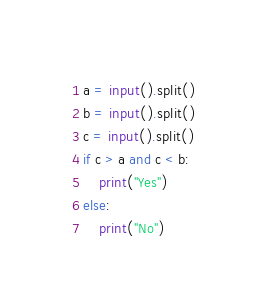Convert code to text. <code><loc_0><loc_0><loc_500><loc_500><_Python_>a = input().split()
b = input().split()
c = input().split()
if c > a and c < b:
	print("Yes")
else:
	print("No")</code> 